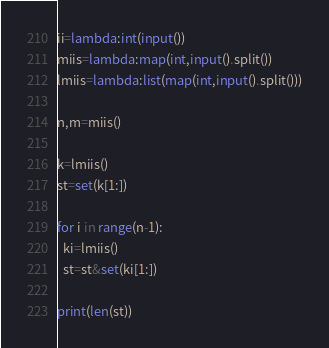<code> <loc_0><loc_0><loc_500><loc_500><_Python_>ii=lambda:int(input())
miis=lambda:map(int,input().split())
lmiis=lambda:list(map(int,input().split()))

n,m=miis()

k=lmiis()
st=set(k[1:])

for i in range(n-1):
  ki=lmiis()
  st=st&set(ki[1:])

print(len(st))</code> 